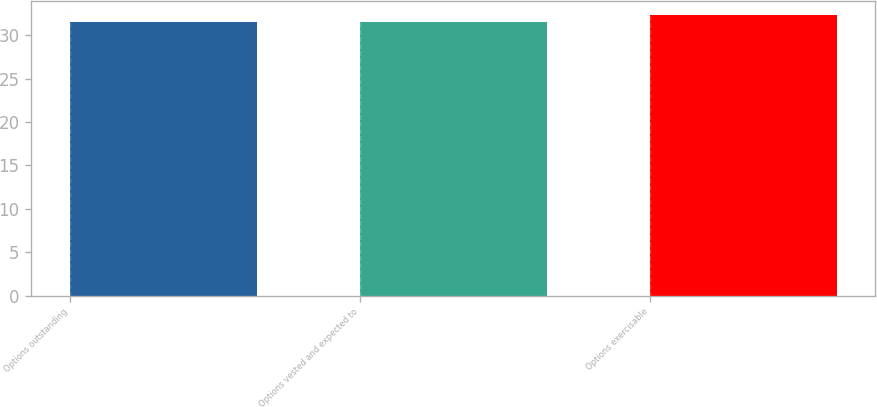Convert chart. <chart><loc_0><loc_0><loc_500><loc_500><bar_chart><fcel>Options outstanding<fcel>Options vested and expected to<fcel>Options exercisable<nl><fcel>31.47<fcel>31.55<fcel>32.31<nl></chart> 